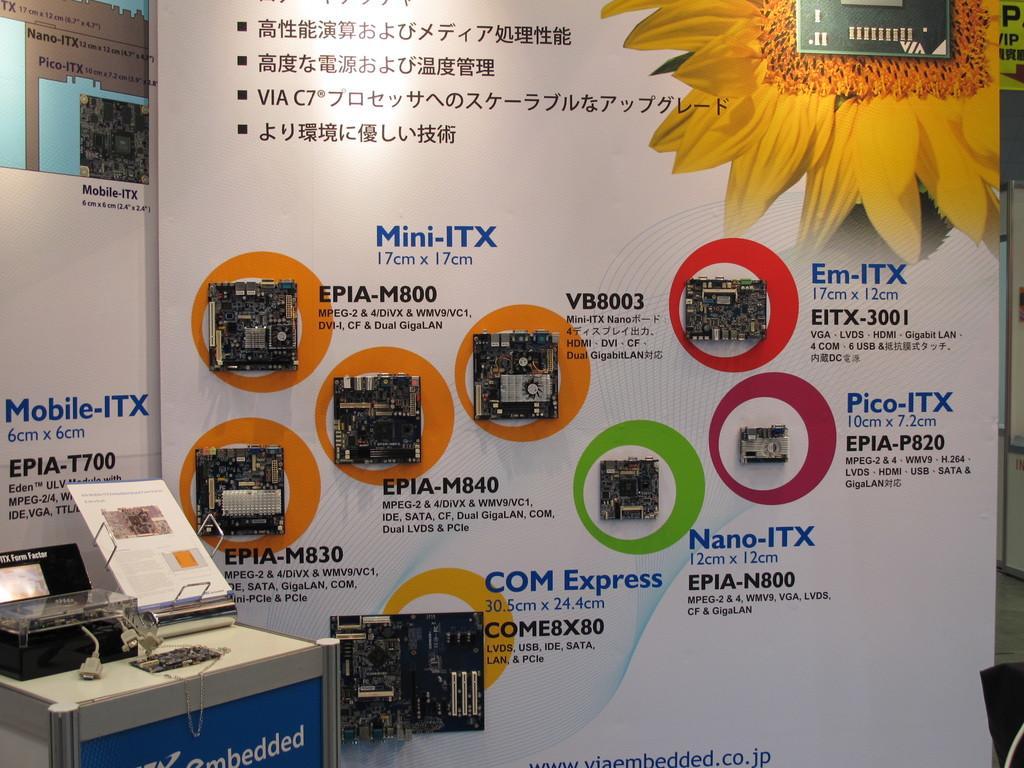Describe this image in one or two sentences. In this image we can see a printing machine on the table, papers and an advertisement. 